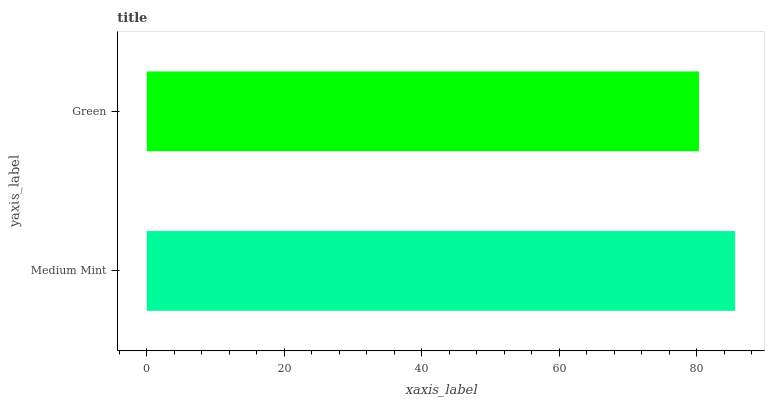Is Green the minimum?
Answer yes or no. Yes. Is Medium Mint the maximum?
Answer yes or no. Yes. Is Green the maximum?
Answer yes or no. No. Is Medium Mint greater than Green?
Answer yes or no. Yes. Is Green less than Medium Mint?
Answer yes or no. Yes. Is Green greater than Medium Mint?
Answer yes or no. No. Is Medium Mint less than Green?
Answer yes or no. No. Is Medium Mint the high median?
Answer yes or no. Yes. Is Green the low median?
Answer yes or no. Yes. Is Green the high median?
Answer yes or no. No. Is Medium Mint the low median?
Answer yes or no. No. 